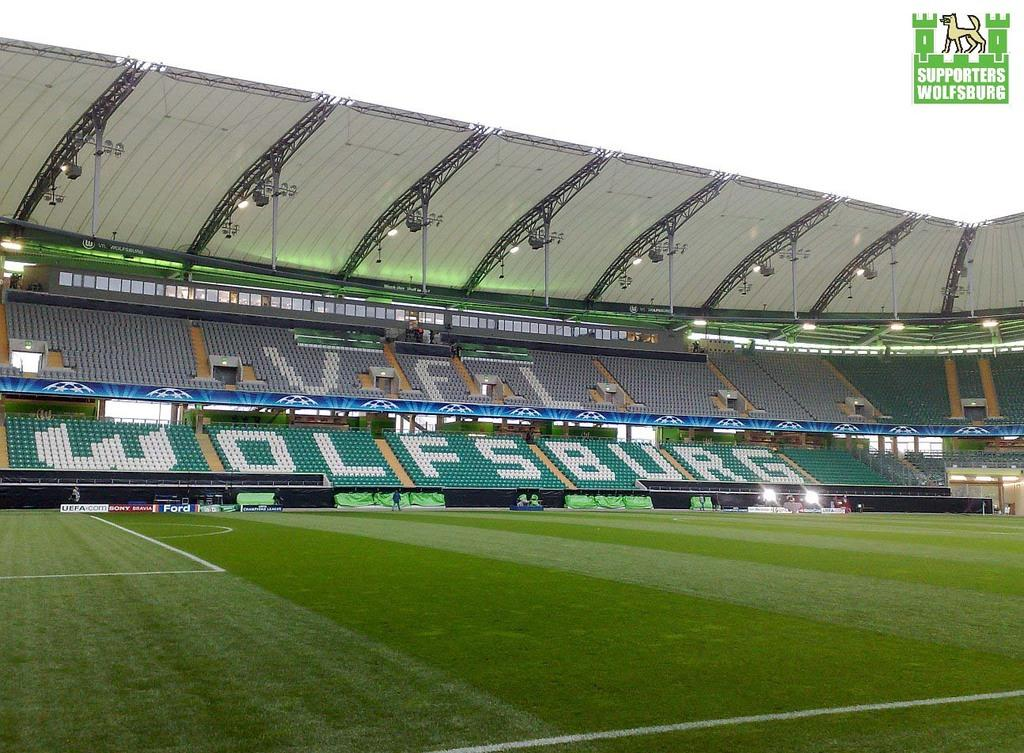<image>
Render a clear and concise summary of the photo. An empty soccer stadium reveals the word Wolfsburg printed on the seats. 